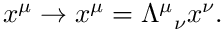Convert formula to latex. <formula><loc_0><loc_0><loc_500><loc_500>x ^ { \mu } \rightarrow x ^ { \mu } = \Lambda ^ { \mu _ { \nu } x ^ { \nu } .</formula> 